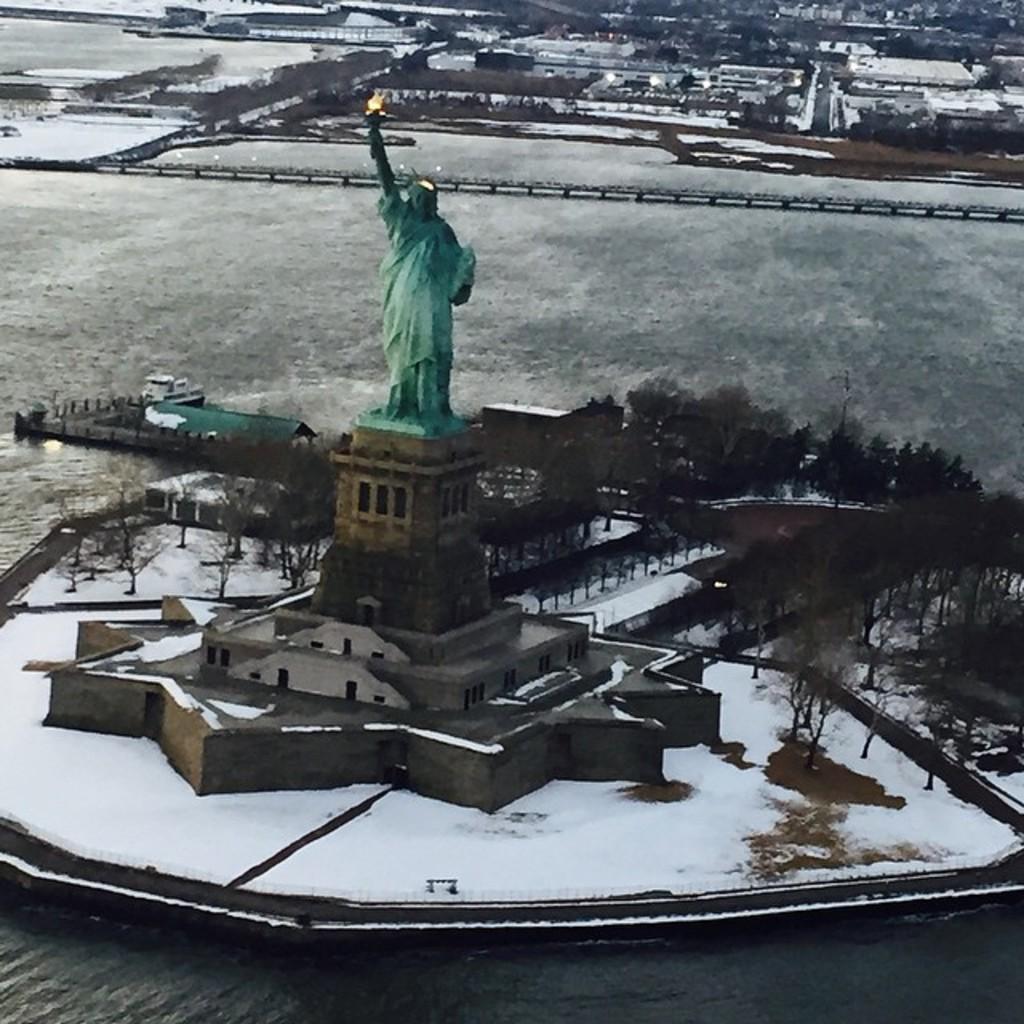Describe this image in one or two sentences. In the image there is a statue in the middle on a building with trees behind it in the middle of sea and in the background, it seems to be trees all over the place. 